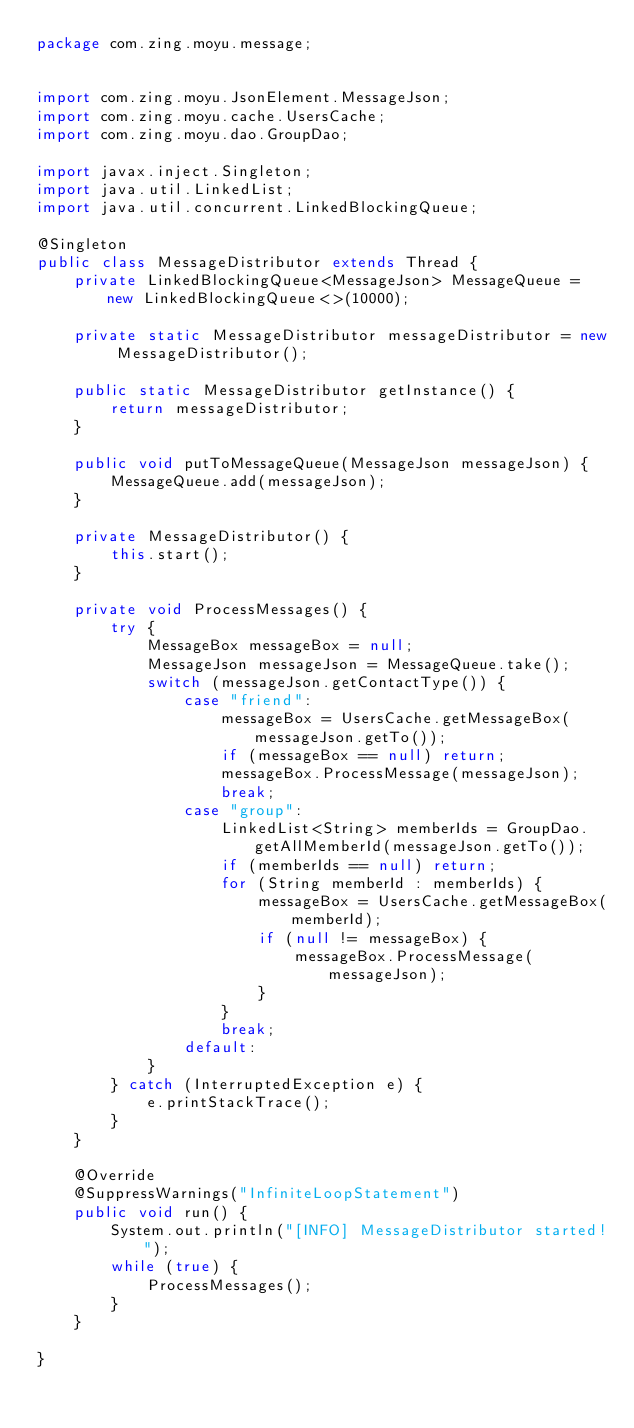Convert code to text. <code><loc_0><loc_0><loc_500><loc_500><_Java_>package com.zing.moyu.message;


import com.zing.moyu.JsonElement.MessageJson;
import com.zing.moyu.cache.UsersCache;
import com.zing.moyu.dao.GroupDao;

import javax.inject.Singleton;
import java.util.LinkedList;
import java.util.concurrent.LinkedBlockingQueue;

@Singleton
public class MessageDistributor extends Thread {
    private LinkedBlockingQueue<MessageJson> MessageQueue = new LinkedBlockingQueue<>(10000);

    private static MessageDistributor messageDistributor = new MessageDistributor();

    public static MessageDistributor getInstance() {
        return messageDistributor;
    }

    public void putToMessageQueue(MessageJson messageJson) {
        MessageQueue.add(messageJson);
    }

    private MessageDistributor() {
        this.start();
    }

    private void ProcessMessages() {
        try {
            MessageBox messageBox = null;
            MessageJson messageJson = MessageQueue.take();
            switch (messageJson.getContactType()) {
                case "friend":
                    messageBox = UsersCache.getMessageBox(messageJson.getTo());
                    if (messageBox == null) return;
                    messageBox.ProcessMessage(messageJson);
                    break;
                case "group":
                    LinkedList<String> memberIds = GroupDao.getAllMemberId(messageJson.getTo());
                    if (memberIds == null) return;
                    for (String memberId : memberIds) {
                        messageBox = UsersCache.getMessageBox(memberId);
                        if (null != messageBox) {
                            messageBox.ProcessMessage(messageJson);
                        }
                    }
                    break;
                default:
            }
        } catch (InterruptedException e) {
            e.printStackTrace();
        }
    }

    @Override
    @SuppressWarnings("InfiniteLoopStatement")
    public void run() {
        System.out.println("[INFO] MessageDistributor started!");
        while (true) {
            ProcessMessages();
        }
    }

}
</code> 